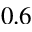<formula> <loc_0><loc_0><loc_500><loc_500>0 . 6</formula> 